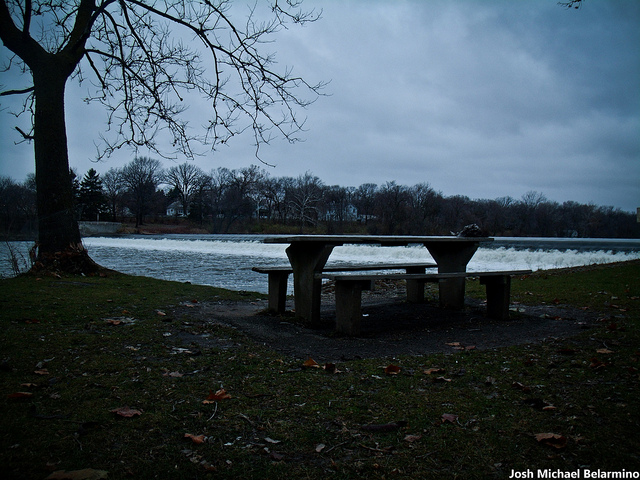Identify the text displayed in this image. Josh Michael Belarmino 